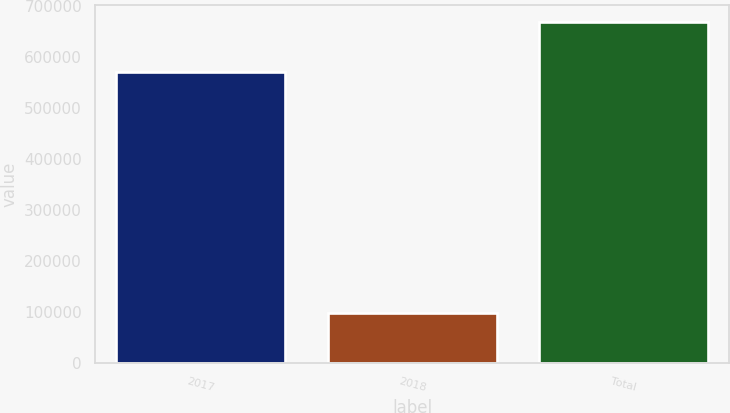Convert chart to OTSL. <chart><loc_0><loc_0><loc_500><loc_500><bar_chart><fcel>2017<fcel>2018<fcel>Total<nl><fcel>570706<fcel>97541<fcel>668247<nl></chart> 